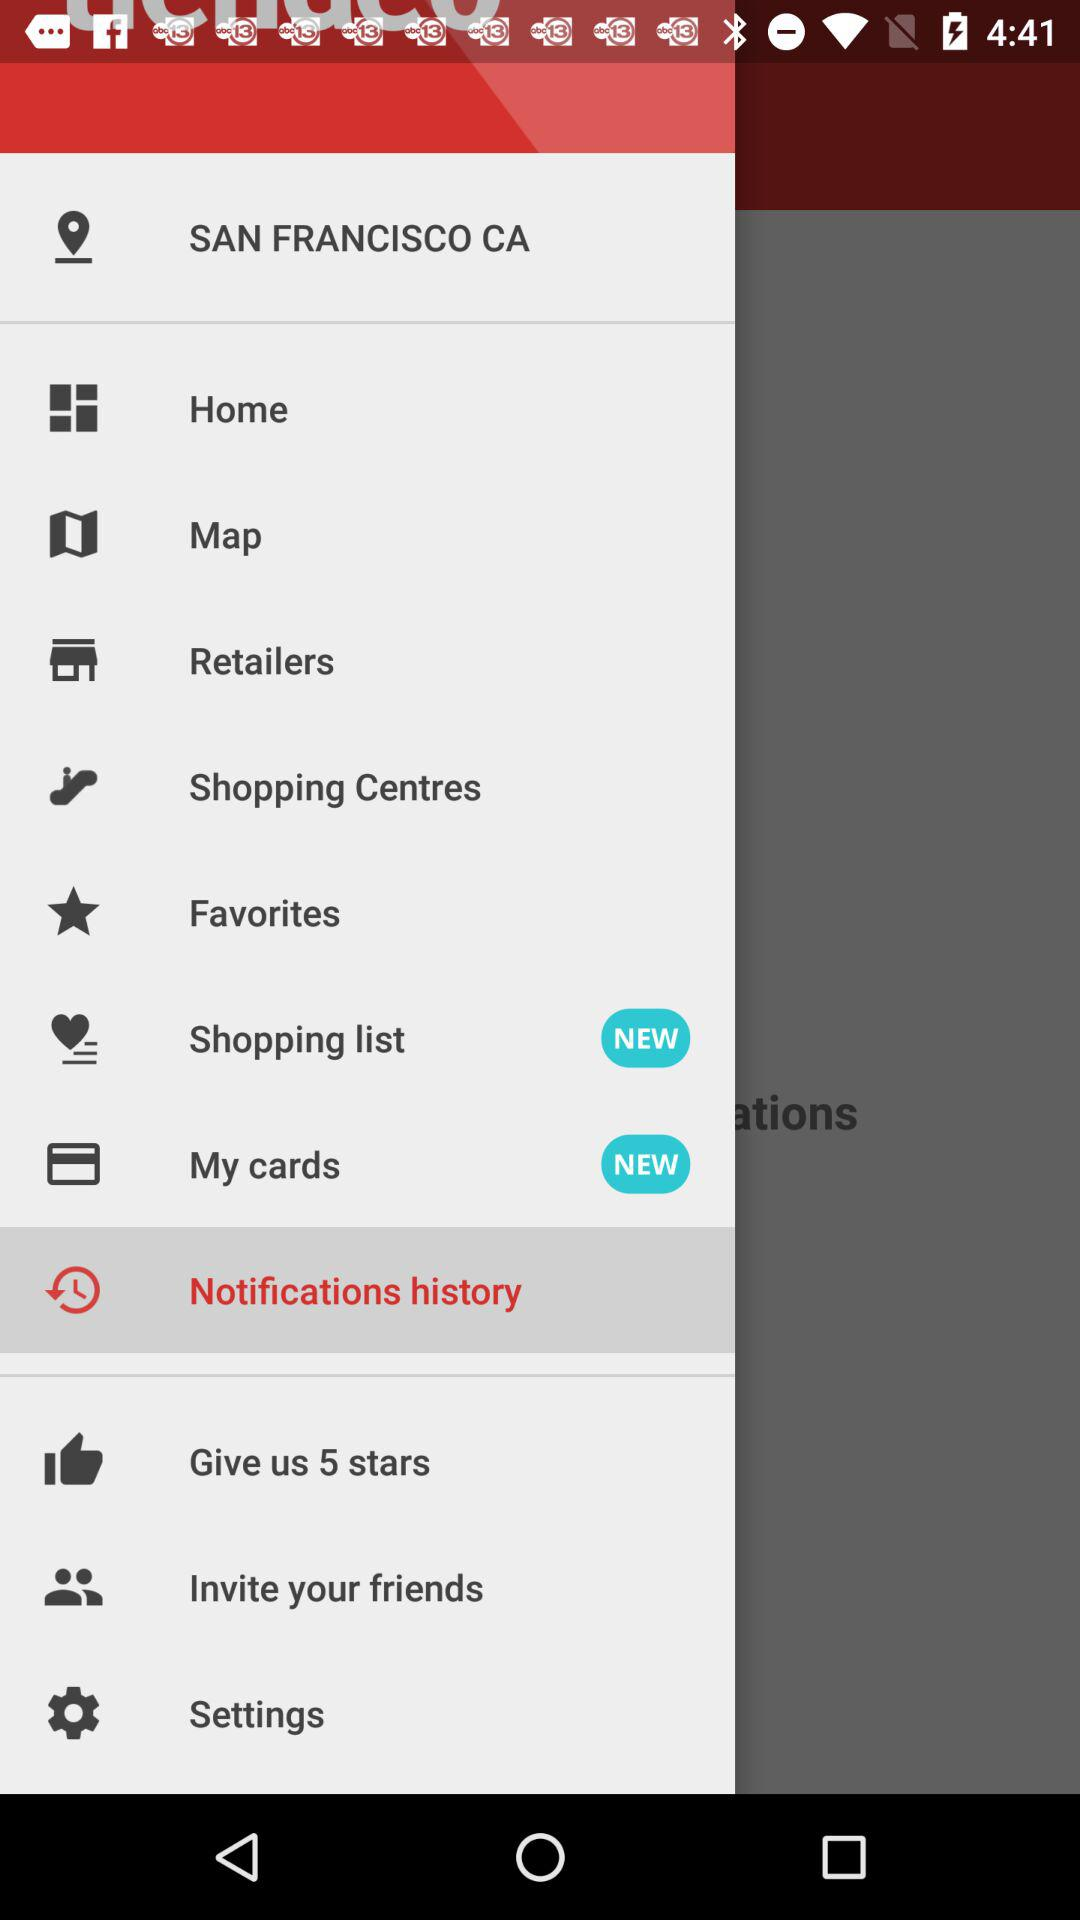What is the location? The location is San Francisco, CA. 